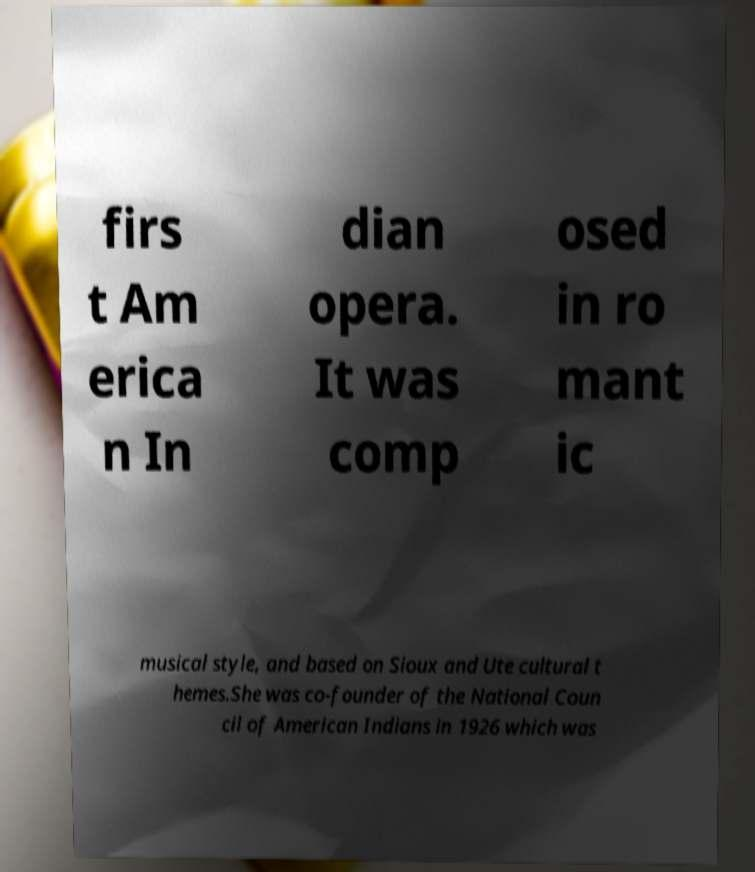I need the written content from this picture converted into text. Can you do that? firs t Am erica n In dian opera. It was comp osed in ro mant ic musical style, and based on Sioux and Ute cultural t hemes.She was co-founder of the National Coun cil of American Indians in 1926 which was 